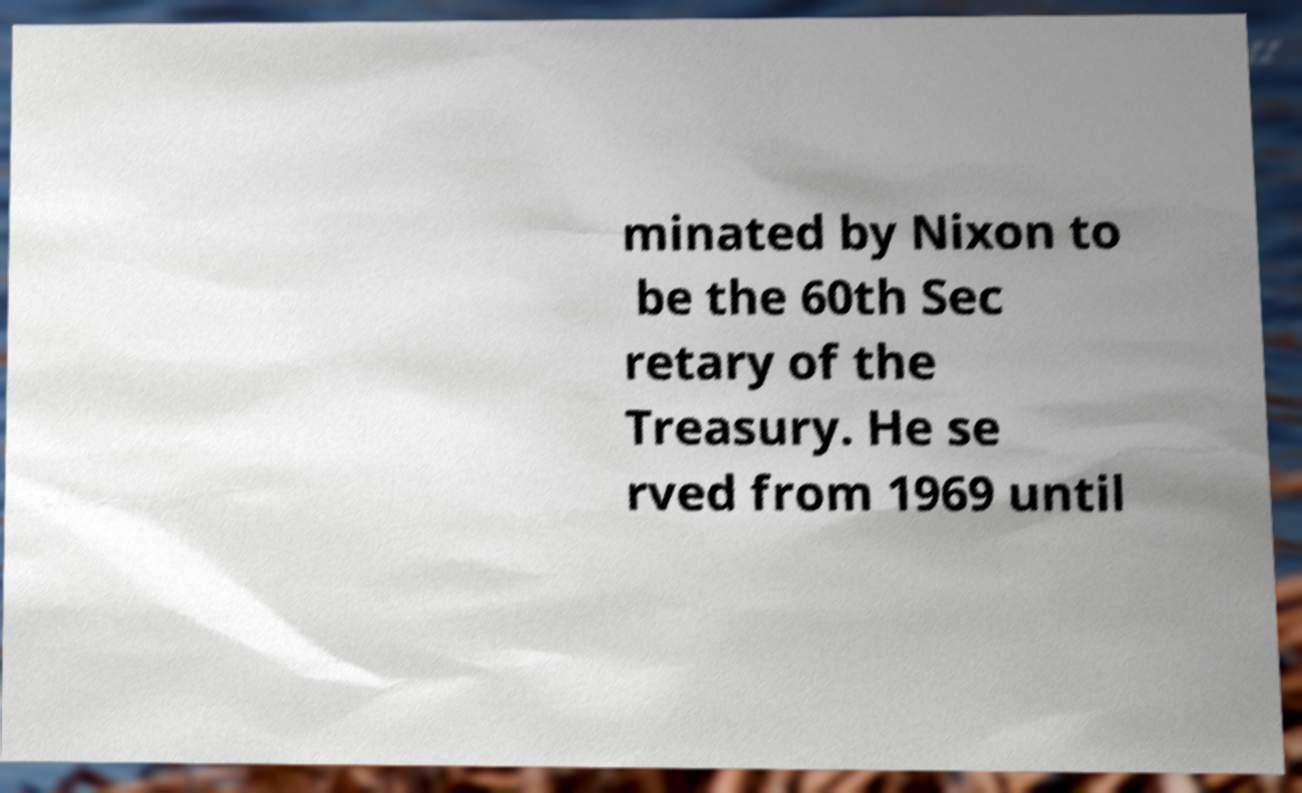Please identify and transcribe the text found in this image. minated by Nixon to be the 60th Sec retary of the Treasury. He se rved from 1969 until 